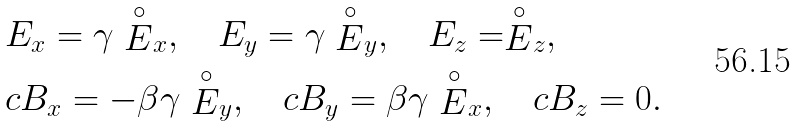Convert formula to latex. <formula><loc_0><loc_0><loc_500><loc_500>& E _ { x } = \gamma \stackrel { \circ } { E } _ { x } , \quad E _ { y } = \gamma \stackrel { \circ } { E } _ { y } , \quad E _ { z } = \stackrel { \circ } { E } _ { z } , \\ & c B _ { x } = - \beta \gamma \stackrel { \circ } { E } _ { y } , \quad c B _ { y } = \beta \gamma \stackrel { \circ } { E } _ { x } , \quad c B _ { z } = 0 .</formula> 